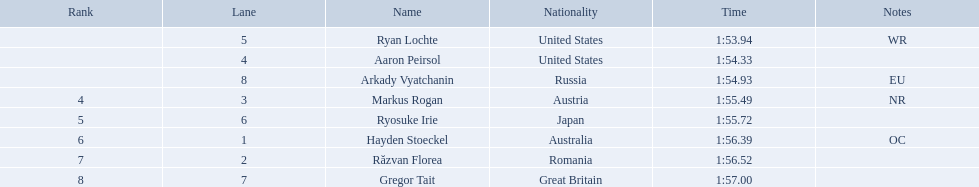Who joined the event? Ryan Lochte, Aaron Peirsol, Arkady Vyatchanin, Markus Rogan, Ryosuke Irie, Hayden Stoeckel, Răzvan Florea, Gregor Tait. Give me the full table as a dictionary. {'header': ['Rank', 'Lane', 'Name', 'Nationality', 'Time', 'Notes'], 'rows': [['', '5', 'Ryan Lochte', 'United States', '1:53.94', 'WR'], ['', '4', 'Aaron Peirsol', 'United States', '1:54.33', ''], ['', '8', 'Arkady Vyatchanin', 'Russia', '1:54.93', 'EU'], ['4', '3', 'Markus Rogan', 'Austria', '1:55.49', 'NR'], ['5', '6', 'Ryosuke Irie', 'Japan', '1:55.72', ''], ['6', '1', 'Hayden Stoeckel', 'Australia', '1:56.39', 'OC'], ['7', '2', 'Răzvan Florea', 'Romania', '1:56.52', ''], ['8', '7', 'Gregor Tait', 'Great Britain', '1:57.00', '']]} What was the end time for each competitor? 1:53.94, 1:54.33, 1:54.93, 1:55.49, 1:55.72, 1:56.39, 1:56.52, 1:57.00. How about solely ryosuke irie? 1:55.72. What is the designation of the competitor in lane 6? Ryosuke Irie. How much time did it take for that participant to finish the race? 1:55.72. What is the name of the competitor in lane 6? Ryosuke Irie. What was their finishing time for the race? 1:55.72. Who are the people involved in the swimming event? Ryan Lochte, Aaron Peirsol, Arkady Vyatchanin, Markus Rogan, Ryosuke Irie, Hayden Stoeckel, Răzvan Florea, Gregor Tait. What is the time recorded by ryosuke irie? 1:55.72. 